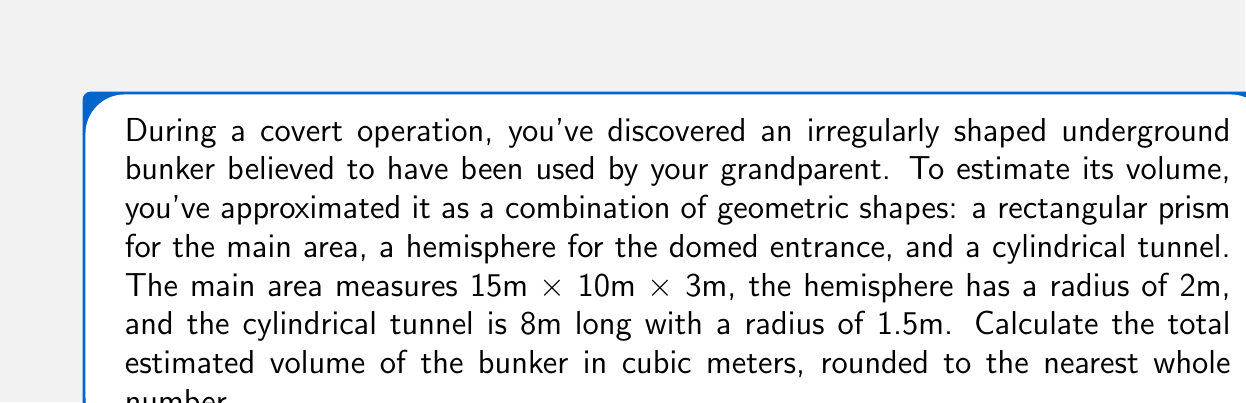Can you answer this question? To solve this problem, we need to calculate the volume of each component and then sum them up:

1. Volume of the rectangular prism (main area):
   $$V_1 = l \times w \times h = 15 \times 10 \times 3 = 450 \text{ m}^3$$

2. Volume of the hemisphere (domed entrance):
   $$V_2 = \frac{2}{3}\pi r^3 = \frac{2}{3}\pi (2)^3 \approx 16.76 \text{ m}^3$$

3. Volume of the cylinder (tunnel):
   $$V_3 = \pi r^2 h = \pi (1.5)^2 (8) \approx 56.55 \text{ m}^3$$

Total volume:
$$V_{\text{total}} = V_1 + V_2 + V_3 = 450 + 16.76 + 56.55 = 523.31 \text{ m}^3$$

Rounding to the nearest whole number:
$$V_{\text{total}} \approx 523 \text{ m}^3$$
Answer: 523 m³ 